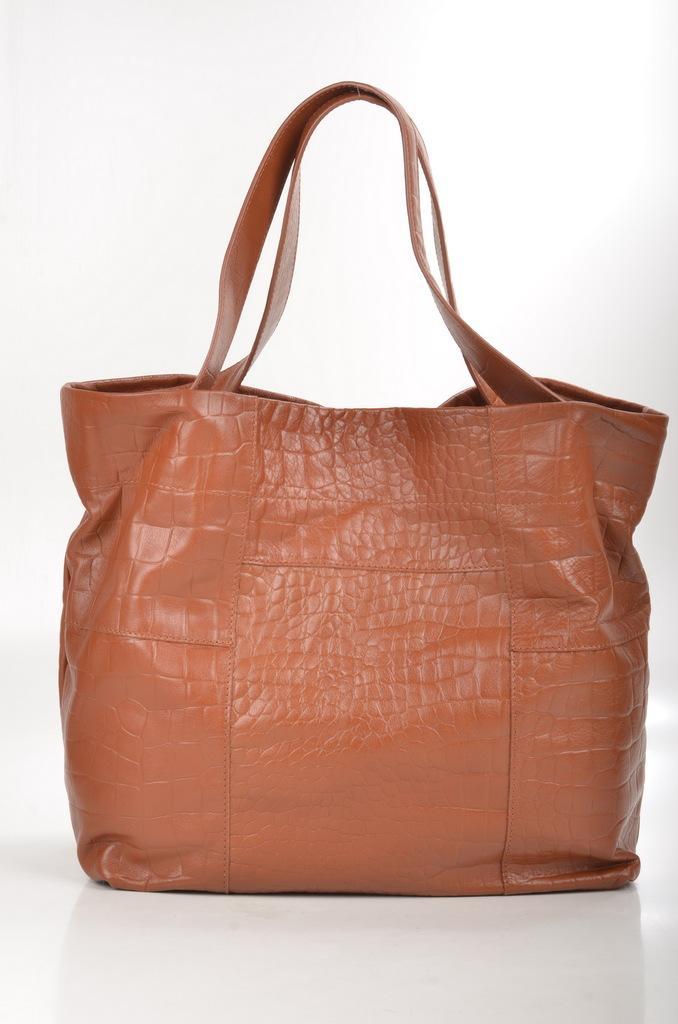Could you give a brief overview of what you see in this image? In this image we can see a bag. 